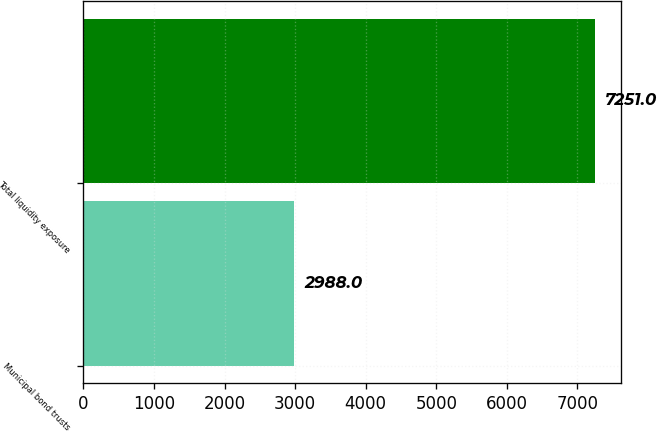Convert chart. <chart><loc_0><loc_0><loc_500><loc_500><bar_chart><fcel>Municipal bond trusts<fcel>Total liquidity exposure<nl><fcel>2988<fcel>7251<nl></chart> 